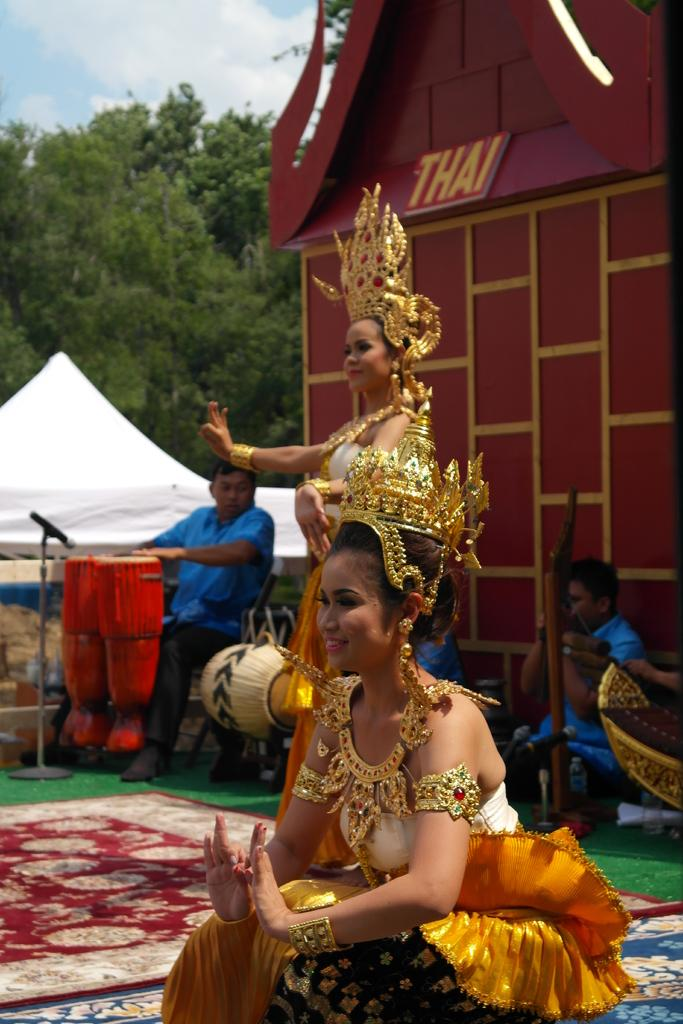How many women are in the image? There are two women in the image. What are the women doing in the image? One woman is sitting, and the other woman is standing. What are the women wearing in the image? Both women are wearing dance costumes. What can be seen in the background of the image? Trees, a clear sky, and a building are visible in the background of the image. What type of vegetable is being harvested by the beggar in the image? There is no vegetable or beggar present in the image. 